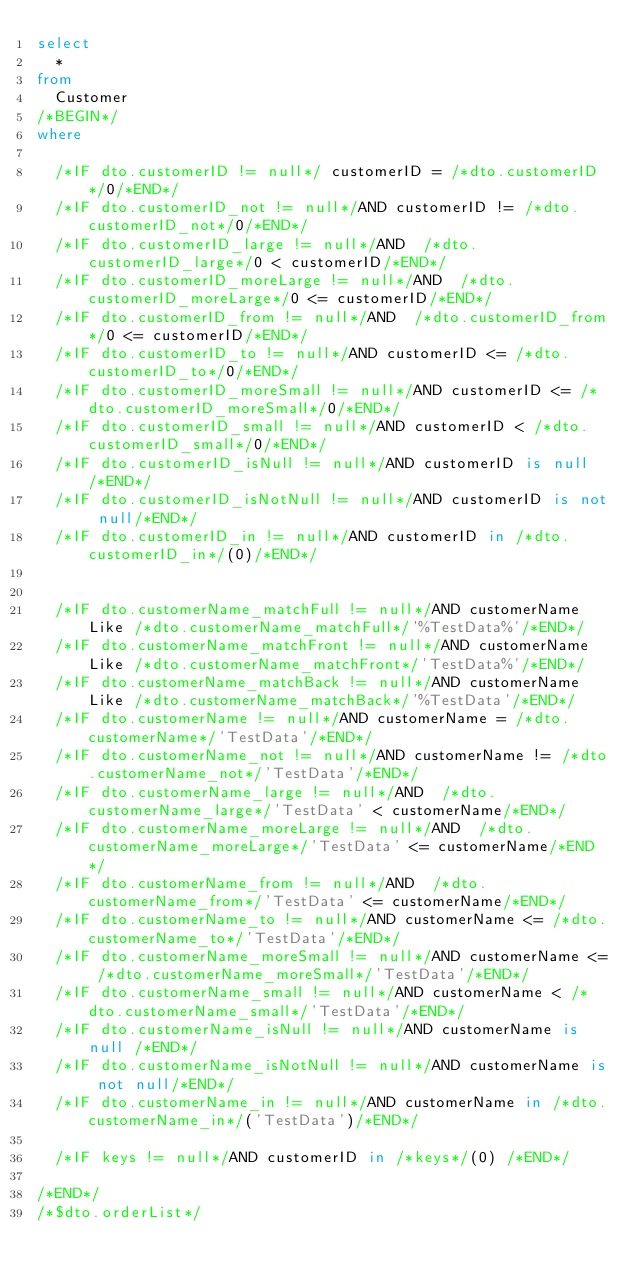<code> <loc_0><loc_0><loc_500><loc_500><_SQL_>select
	*
from
	Customer
/*BEGIN*/
where
	
	/*IF dto.customerID != null*/ customerID = /*dto.customerID*/0/*END*/
	/*IF dto.customerID_not != null*/AND customerID != /*dto.customerID_not*/0/*END*/
	/*IF dto.customerID_large != null*/AND  /*dto.customerID_large*/0 < customerID/*END*/
	/*IF dto.customerID_moreLarge != null*/AND  /*dto.customerID_moreLarge*/0 <= customerID/*END*/
	/*IF dto.customerID_from != null*/AND  /*dto.customerID_from*/0 <= customerID/*END*/
	/*IF dto.customerID_to != null*/AND customerID <= /*dto.customerID_to*/0/*END*/
	/*IF dto.customerID_moreSmall != null*/AND customerID <= /*dto.customerID_moreSmall*/0/*END*/
	/*IF dto.customerID_small != null*/AND customerID < /*dto.customerID_small*/0/*END*/
	/*IF dto.customerID_isNull != null*/AND customerID is null /*END*/
	/*IF dto.customerID_isNotNull != null*/AND customerID is not null/*END*/
	/*IF dto.customerID_in != null*/AND customerID in /*dto.customerID_in*/(0)/*END*/

	
	/*IF dto.customerName_matchFull != null*/AND customerName Like /*dto.customerName_matchFull*/'%TestData%'/*END*/
	/*IF dto.customerName_matchFront != null*/AND customerName Like /*dto.customerName_matchFront*/'TestData%'/*END*/
	/*IF dto.customerName_matchBack != null*/AND customerName Like /*dto.customerName_matchBack*/'%TestData'/*END*/
	/*IF dto.customerName != null*/AND customerName = /*dto.customerName*/'TestData'/*END*/
	/*IF dto.customerName_not != null*/AND customerName != /*dto.customerName_not*/'TestData'/*END*/
	/*IF dto.customerName_large != null*/AND  /*dto.customerName_large*/'TestData' < customerName/*END*/
	/*IF dto.customerName_moreLarge != null*/AND  /*dto.customerName_moreLarge*/'TestData' <= customerName/*END*/
	/*IF dto.customerName_from != null*/AND  /*dto.customerName_from*/'TestData' <= customerName/*END*/
	/*IF dto.customerName_to != null*/AND customerName <= /*dto.customerName_to*/'TestData'/*END*/
	/*IF dto.customerName_moreSmall != null*/AND customerName <= /*dto.customerName_moreSmall*/'TestData'/*END*/
	/*IF dto.customerName_small != null*/AND customerName < /*dto.customerName_small*/'TestData'/*END*/
	/*IF dto.customerName_isNull != null*/AND customerName is null /*END*/
	/*IF dto.customerName_isNotNull != null*/AND customerName is not null/*END*/
	/*IF dto.customerName_in != null*/AND customerName in /*dto.customerName_in*/('TestData')/*END*/

	/*IF keys != null*/AND customerID in /*keys*/(0) /*END*/
	
/*END*/
/*$dto.orderList*/
</code> 